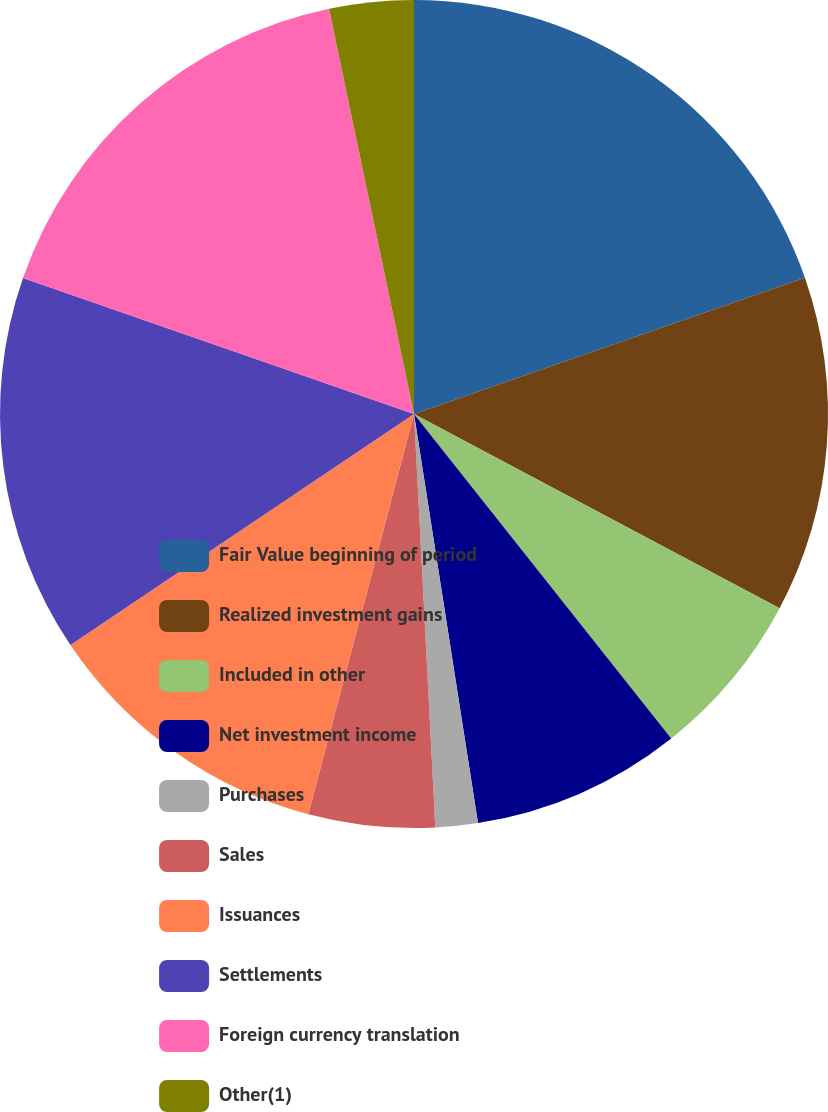<chart> <loc_0><loc_0><loc_500><loc_500><pie_chart><fcel>Fair Value beginning of period<fcel>Realized investment gains<fcel>Included in other<fcel>Net investment income<fcel>Purchases<fcel>Sales<fcel>Issuances<fcel>Settlements<fcel>Foreign currency translation<fcel>Other(1)<nl><fcel>19.66%<fcel>13.11%<fcel>6.56%<fcel>8.2%<fcel>1.65%<fcel>4.93%<fcel>11.47%<fcel>14.75%<fcel>16.38%<fcel>3.29%<nl></chart> 